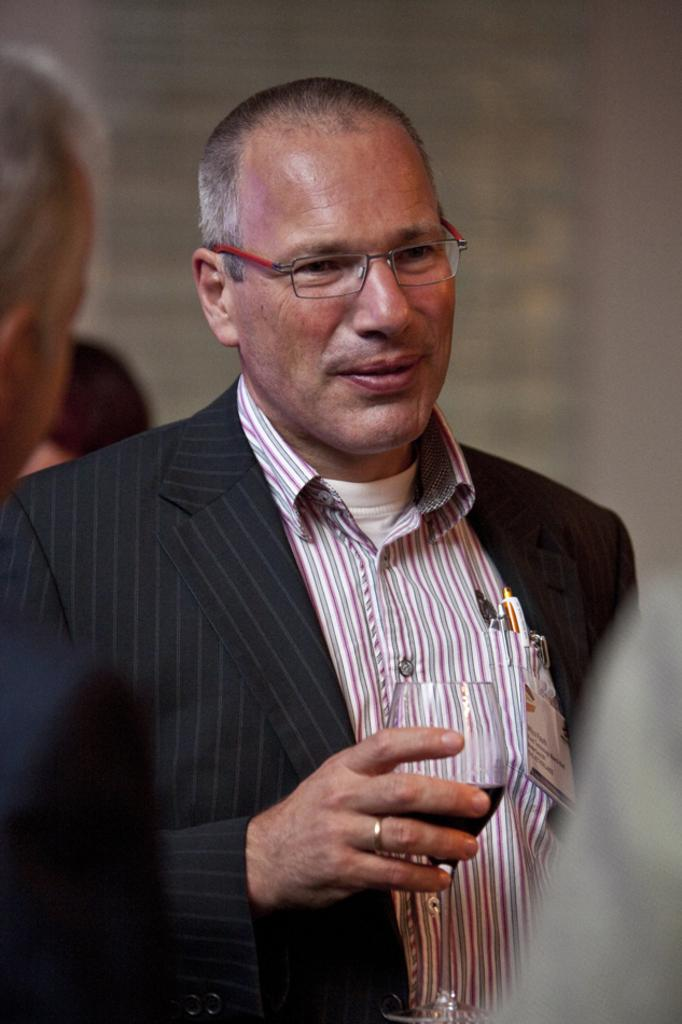What is the main subject in the middle of the image? There is a person in the middle of the image. What is the person in the middle wearing? The person in the middle is wearing a suit and shirt. What is the person in the middle holding? The person in the middle is holding a glass. Can you describe the people surrounding the person in the middle? There is another person behind the person in the middle and two people in front of the person in the middle. What type of glass can be seen on the sidewalk in the image? There is no glass or sidewalk present in the image; it features a person in the middle holding a glass. 